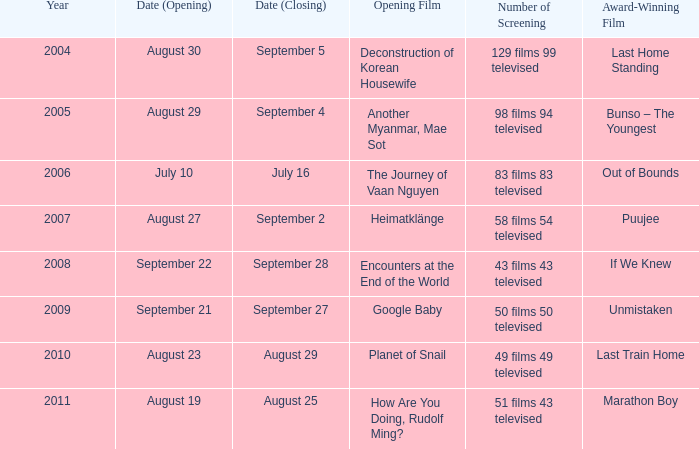Which award-winning film has a closing date of September 4? Bunso – The Youngest. 